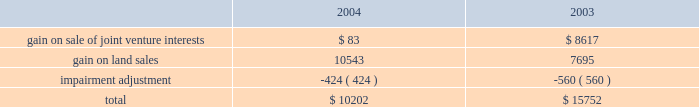Management 2019s discussion and analysis of financial condition and results of operations maturity at an effective rate of 6.33% ( 6.33 % ) .
In december we issued $ 250 million of unsecured floating rate debt at 26 basis points over libor .
The debt matures in two years , but is callable at our option after six months .
25cf in august , we paid off $ 15 million of a $ 40 million secured floating rate term loan .
We also assumed $ 29.9 million of secured debt in conjunction with a property acquisition in atlanta .
25cf the average balance and average borrowing rate of our $ 500 million revolving credit facility were slightly higher in 2004 than in 2003 .
At the end of 2004 we were not utilizing our credit facility .
Depreciation and amortization expense depreciation and amortization expense increased from $ 188.0 million in 2003 to $ 224.6 million in 2004 as a result of increased capital spending associated with increased leasing , the additional basis resulting from acquisitions , development activity and the application of sfas 141 as described below .
The points below highlight the significant increase in depreciation and amortization .
25cf depreciation expense on tenant improvements increased by $ 14.1 million .
25cf depreciation expense on buildings increased by $ 6.0 million .
25cf lease commission amortization increased by $ 2.2 million .
The amortization expense associated with acquired lease intangible assets increased by approximately $ 10.0 million .
The acquisitions were accounted for in accordance with sfas 141 which requires the allocation of a portion of a property 2019s purchase price to intangible assets for leases acquired and in-place at the closing date of the acquisition .
These intangible assets are amortized over the remaining life of the leases ( generally 3-5 years ) as compared to the building basis portion of the acquisition , which is depreciated over 40 years .
Service operations service operations primarily consist of our merchant building sales and the leasing , management , construction and development services for joint venture properties and properties owned by third parties .
These operations are heavily influenced by the current state of the economy as leasing and management fees are dependent upon occupancy while construction and development services rely on businesses expanding operations .
Service operations earnings increased from $ 21.8 million in 2003 to $ 24.4 million in 2004 .
The increase reflects higher construction volumes partially offset by increased staffing costs for our new national development and construction group and construction jobs in certain markets .
Other factors impacting service operations are discussed below .
25cf we experienced a 1.6% ( 1.6 % ) decrease in our overall gross profit margin percentage in our general contractor business in 2004 as compared to 2003 , due to continued competitive pricing pressure in many of our markets .
We expect margins to increase in 2005 as economic conditions improve .
However , despite this decrease , we were able to increase our net general contractor revenues from $ 26.8 million in 2003 to $ 27.6 million in 2004 because of an increase in volume .
This volume increase was attributable to continued low financing costs available to businesses , thereby making it more attractive for them to own instead of lease facilities .
We have a substantial backlog of $ 183.2 million for third party construction as of december 31 , 2004 , that will carry into 2005 .
25cf our merchant building development and sales program , whereby a building is developed by us and then sold , is a significant component of construction and development income .
During 2004 , we generated after tax gains of $ 16.5 million from the sale of six properties compared to $ 9.6 million from the sale of four properties in 2003 .
Profit margins on these types of building sales fluctuate by sale depending on the type of property being sold , the strength of the underlying tenant and nature of the sale , such as a pre-contracted purchase price for a primary tenant versus a sale on the open market .
General and administrative expense general and administrative expense increased from $ 22.1 million in 2003 to $ 26.4 million in 2004 .
The increase was a result of increased staffing and employee compensation costs to support development of our national development and construction group .
We also experienced an increase in marketing to support certain new projects .
Other income and expenses earnings from sales of land and ownership interests in unconsolidated companies , net of impairment adjustments , is comprised of the following amounts in 2004 and 2003 ( in thousands ) : .
In the first quarter of 2003 , we sold our 50% ( 50 % ) interest in a joint venture that owned and operated depreciable investment property .
The joint venture developed and operated real estate assets ; thus , the gain was not included in operating income. .
In 2004 what was the ratio of the increase in the depreciation expense on the tenant improvement to the buildings? 
Computations: (14.1 / 6)
Answer: 2.35. 